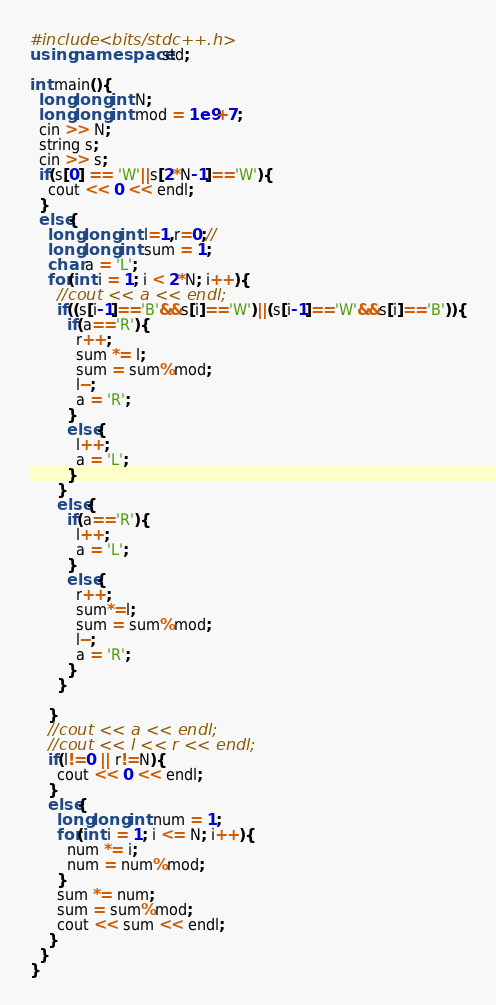<code> <loc_0><loc_0><loc_500><loc_500><_C++_>#include <bits/stdc++.h>
using namespace std;

int main(){
  long long int N;
  long long int mod = 1e9+7;
  cin >> N;
  string s;
  cin >> s;
  if(s[0] == 'W'||s[2*N-1]=='W'){
    cout << 0 << endl;
  }
  else{
    long long int l=1,r=0;//
    long long int sum = 1;
    char a = 'L';
    for(int i = 1; i < 2*N; i++){
      //cout << a << endl;
      if((s[i-1]=='B'&&s[i]=='W')||(s[i-1]=='W'&&s[i]=='B')){
        if(a=='R'){
          r++;
          sum *= l;
          sum = sum%mod;
          l--;
          a = 'R';
        }
        else{
          l++;
          a = 'L';
        }
      }
      else{
        if(a=='R'){
          l++;
          a = 'L';
        }
        else{
          r++;
          sum*=l;
          sum = sum%mod;
          l--;
          a = 'R';
        }
      }
      
    }
    //cout << a << endl;
    //cout << l << r << endl;
    if(l!=0 || r!=N){
      cout << 0 << endl;
    }
    else{
      long long int num = 1;
      for(int i = 1; i <= N; i++){
        num *= i;
        num = num%mod;
      }
      sum *= num;
      sum = sum%mod;
      cout << sum << endl;
    }
  }
}
</code> 